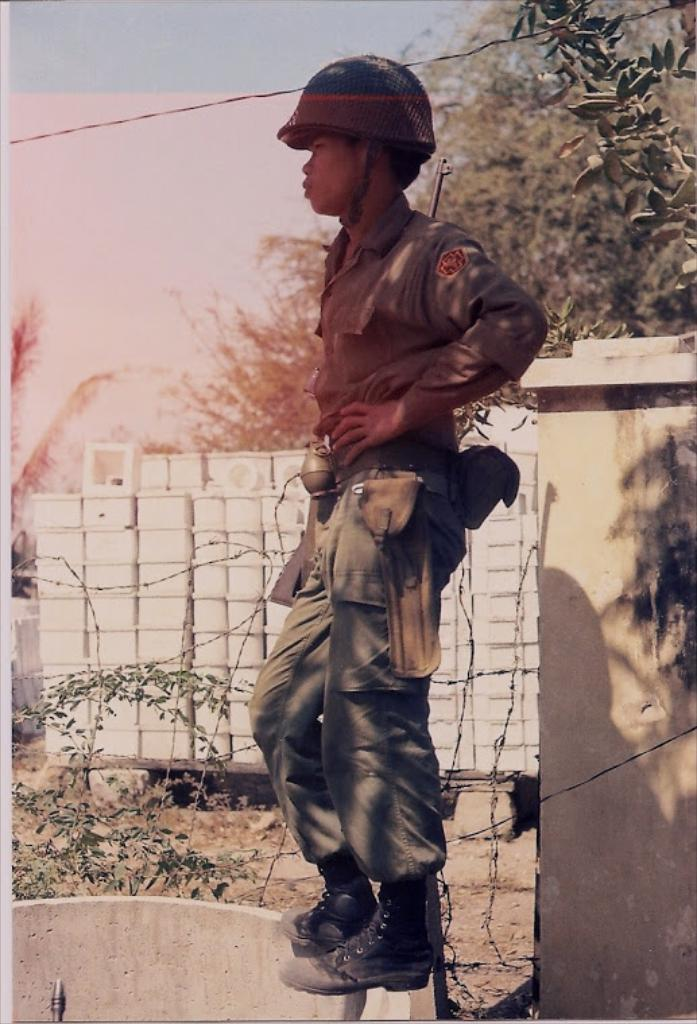What is the main subject of the image? There is a man standing in the image. What can be seen behind the man? There is a wall in the image. Are there any plants visible in the image? Yes, there is a plant in the image. What type of natural environment is visible in the image? There are trees in the image. What is visible at the top of the image? The sky is visible at the top of the image. What type of bread can be seen on the wall in the image? There is no bread present in the image; it features a man standing in front of a wall with a plant and trees in the background. What type of wine is the man holding in the image? There is no wine present in the image; the man is not holding any objects. 